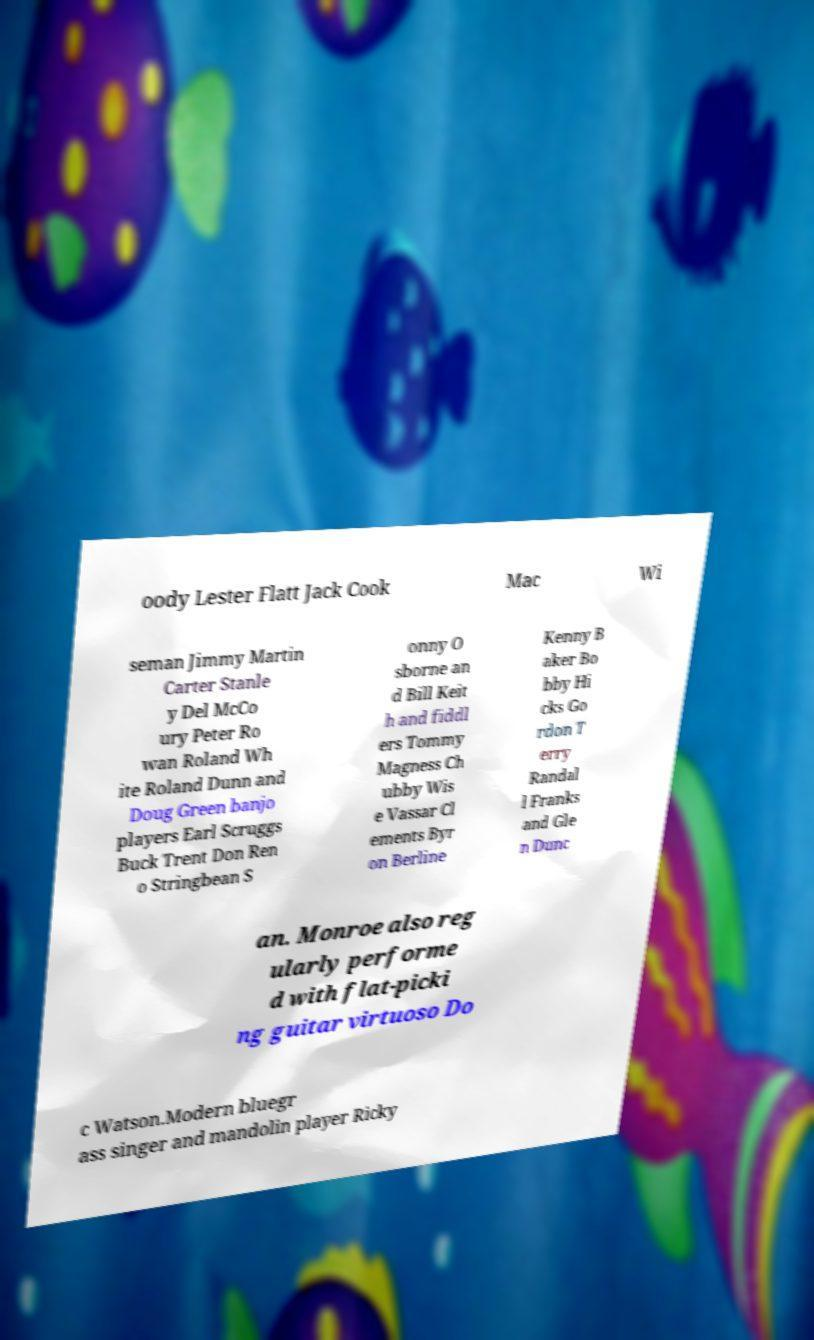Can you read and provide the text displayed in the image?This photo seems to have some interesting text. Can you extract and type it out for me? oody Lester Flatt Jack Cook Mac Wi seman Jimmy Martin Carter Stanle y Del McCo ury Peter Ro wan Roland Wh ite Roland Dunn and Doug Green banjo players Earl Scruggs Buck Trent Don Ren o Stringbean S onny O sborne an d Bill Keit h and fiddl ers Tommy Magness Ch ubby Wis e Vassar Cl ements Byr on Berline Kenny B aker Bo bby Hi cks Go rdon T erry Randal l Franks and Gle n Dunc an. Monroe also reg ularly performe d with flat-picki ng guitar virtuoso Do c Watson.Modern bluegr ass singer and mandolin player Ricky 